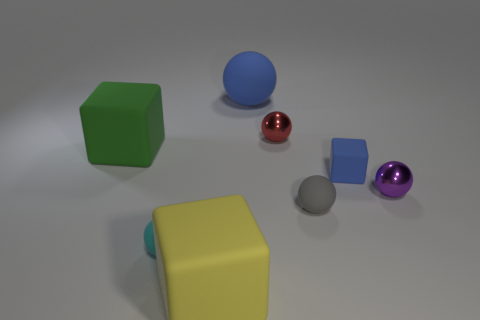Are any gray things visible?
Provide a succinct answer. Yes. There is a matte ball that is behind the blue matte block; how many rubber things are to the right of it?
Your response must be concise. 2. The blue rubber object behind the small blue object has what shape?
Your response must be concise. Sphere. There is a blue thing behind the big cube behind the tiny rubber sphere on the left side of the gray matte object; what is it made of?
Ensure brevity in your answer.  Rubber. How many other objects are the same size as the blue cube?
Offer a terse response. 4. There is another large object that is the same shape as the gray rubber thing; what is it made of?
Ensure brevity in your answer.  Rubber. The small block has what color?
Your answer should be very brief. Blue. There is a big matte cube that is behind the big rubber thing in front of the small cyan rubber ball; what is its color?
Your answer should be very brief. Green. There is a large rubber sphere; is its color the same as the small cube that is to the right of the green cube?
Make the answer very short. Yes. What number of tiny red spheres are behind the big cube in front of the matte block to the left of the cyan matte sphere?
Keep it short and to the point. 1. 